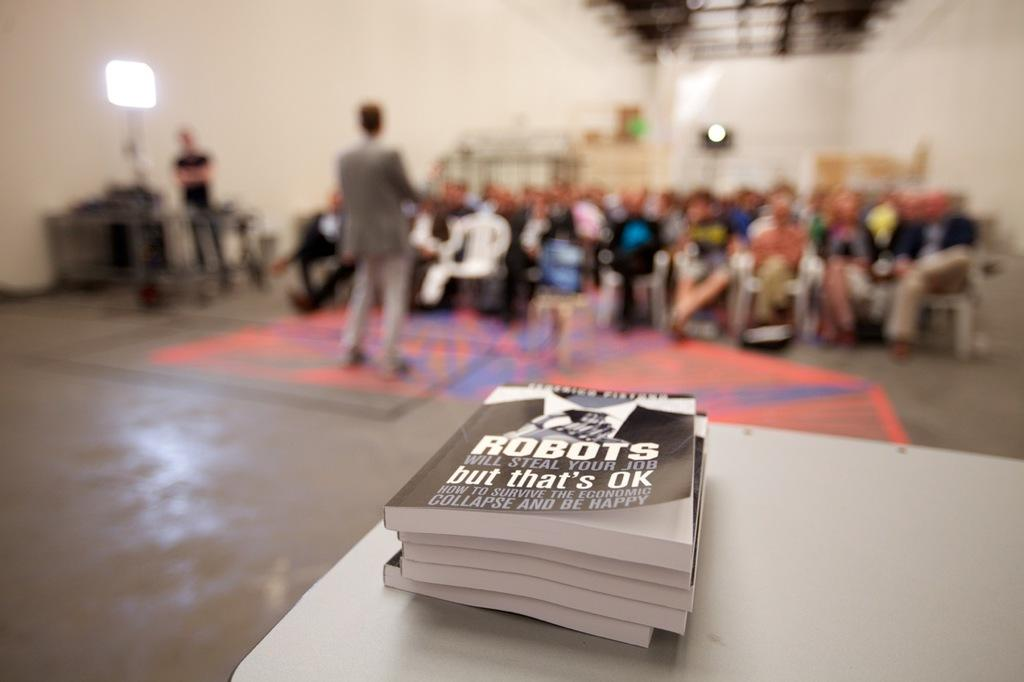Provide a one-sentence caption for the provided image. A white table has a stack of books named ROBOTS WILL STEAL YOUR JOB. 